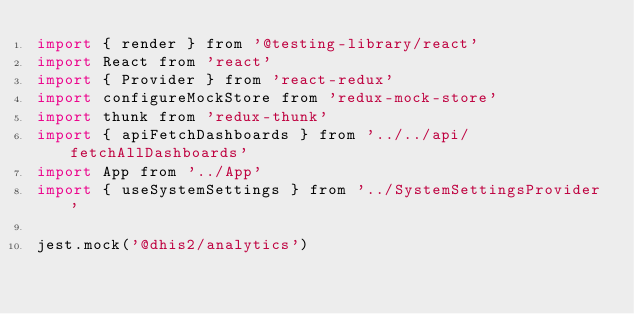Convert code to text. <code><loc_0><loc_0><loc_500><loc_500><_JavaScript_>import { render } from '@testing-library/react'
import React from 'react'
import { Provider } from 'react-redux'
import configureMockStore from 'redux-mock-store'
import thunk from 'redux-thunk'
import { apiFetchDashboards } from '../../api/fetchAllDashboards'
import App from '../App'
import { useSystemSettings } from '../SystemSettingsProvider'

jest.mock('@dhis2/analytics')
</code> 